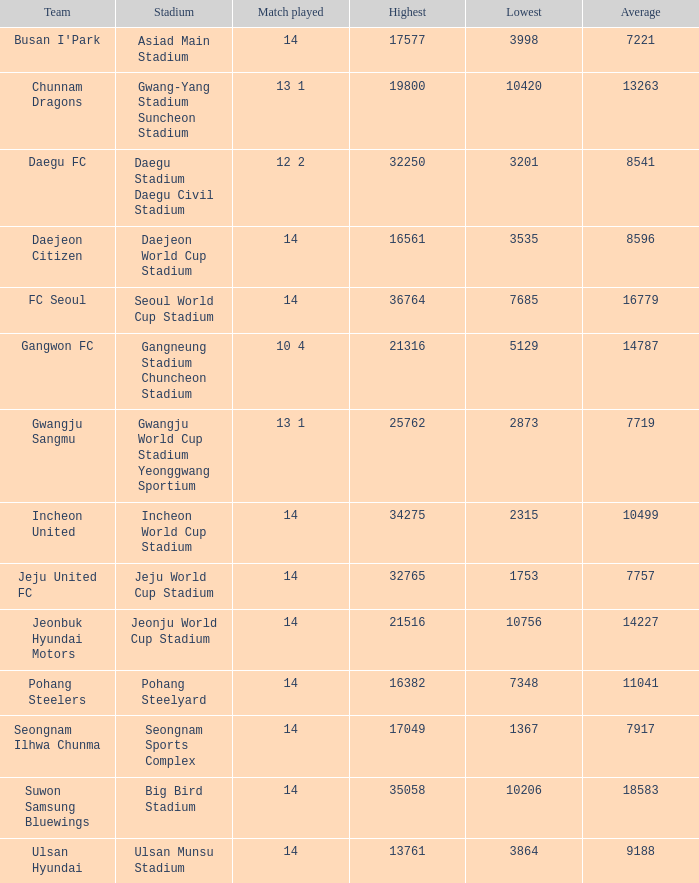Which team has a match played of 10 4? Gangwon FC. Parse the full table. {'header': ['Team', 'Stadium', 'Match played', 'Highest', 'Lowest', 'Average'], 'rows': [["Busan I'Park", 'Asiad Main Stadium', '14', '17577', '3998', '7221'], ['Chunnam Dragons', 'Gwang-Yang Stadium Suncheon Stadium', '13 1', '19800', '10420', '13263'], ['Daegu FC', 'Daegu Stadium Daegu Civil Stadium', '12 2', '32250', '3201', '8541'], ['Daejeon Citizen', 'Daejeon World Cup Stadium', '14', '16561', '3535', '8596'], ['FC Seoul', 'Seoul World Cup Stadium', '14', '36764', '7685', '16779'], ['Gangwon FC', 'Gangneung Stadium Chuncheon Stadium', '10 4', '21316', '5129', '14787'], ['Gwangju Sangmu', 'Gwangju World Cup Stadium Yeonggwang Sportium', '13 1', '25762', '2873', '7719'], ['Incheon United', 'Incheon World Cup Stadium', '14', '34275', '2315', '10499'], ['Jeju United FC', 'Jeju World Cup Stadium', '14', '32765', '1753', '7757'], ['Jeonbuk Hyundai Motors', 'Jeonju World Cup Stadium', '14', '21516', '10756', '14227'], ['Pohang Steelers', 'Pohang Steelyard', '14', '16382', '7348', '11041'], ['Seongnam Ilhwa Chunma', 'Seongnam Sports Complex', '14', '17049', '1367', '7917'], ['Suwon Samsung Bluewings', 'Big Bird Stadium', '14', '35058', '10206', '18583'], ['Ulsan Hyundai', 'Ulsan Munsu Stadium', '14', '13761', '3864', '9188']]} 